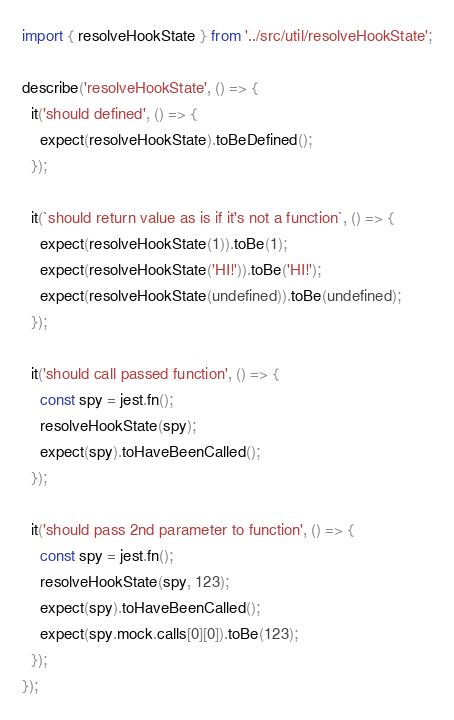<code> <loc_0><loc_0><loc_500><loc_500><_TypeScript_>import { resolveHookState } from '../src/util/resolveHookState';

describe('resolveHookState', () => {
  it('should defined', () => {
    expect(resolveHookState).toBeDefined();
  });

  it(`should return value as is if it's not a function`, () => {
    expect(resolveHookState(1)).toBe(1);
    expect(resolveHookState('HI!')).toBe('HI!');
    expect(resolveHookState(undefined)).toBe(undefined);
  });

  it('should call passed function', () => {
    const spy = jest.fn();
    resolveHookState(spy);
    expect(spy).toHaveBeenCalled();
  });

  it('should pass 2nd parameter to function', () => {
    const spy = jest.fn();
    resolveHookState(spy, 123);
    expect(spy).toHaveBeenCalled();
    expect(spy.mock.calls[0][0]).toBe(123);
  });
});
</code> 